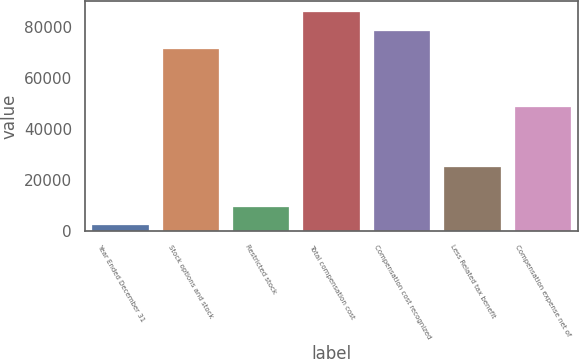<chart> <loc_0><loc_0><loc_500><loc_500><bar_chart><fcel>Year Ended December 31<fcel>Stock options and stock<fcel>Restricted stock<fcel>Total compensation cost<fcel>Compensation cost recognized<fcel>Less Related tax benefit<fcel>Compensation expense net of<nl><fcel>2006<fcel>71386<fcel>9247.8<fcel>85869.6<fcel>78627.8<fcel>24901<fcel>48725<nl></chart> 